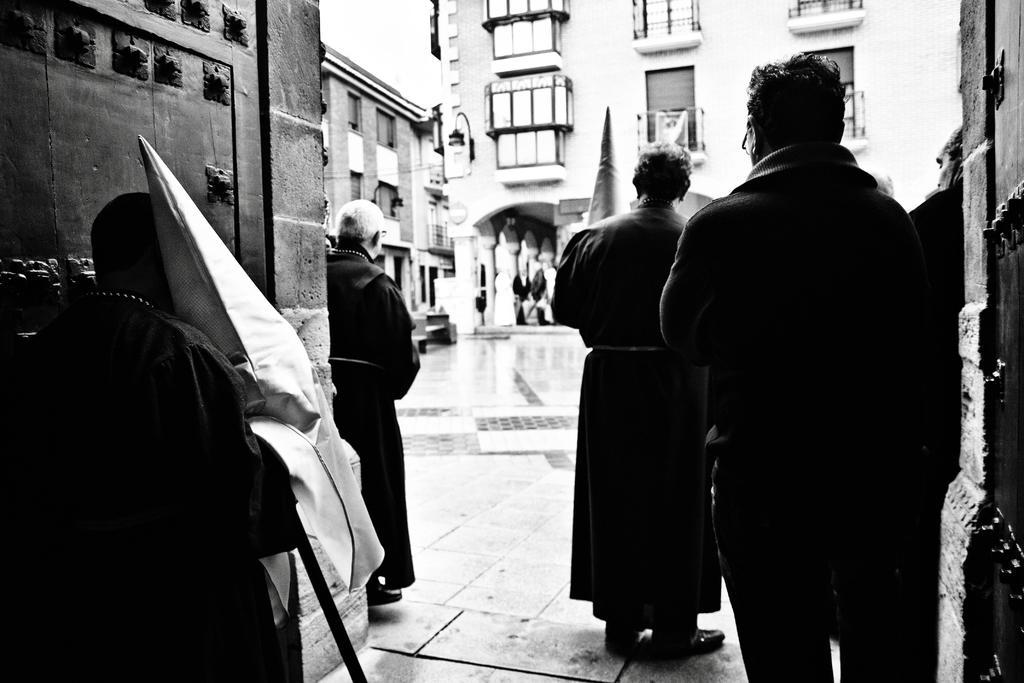Describe this image in one or two sentences. This is a black and white image. On the left side of the image we can see man holding a flag and a person standing on the ground. On the right side of the image there are persons standing on the ground. In the background there is a building, water and a sky. 